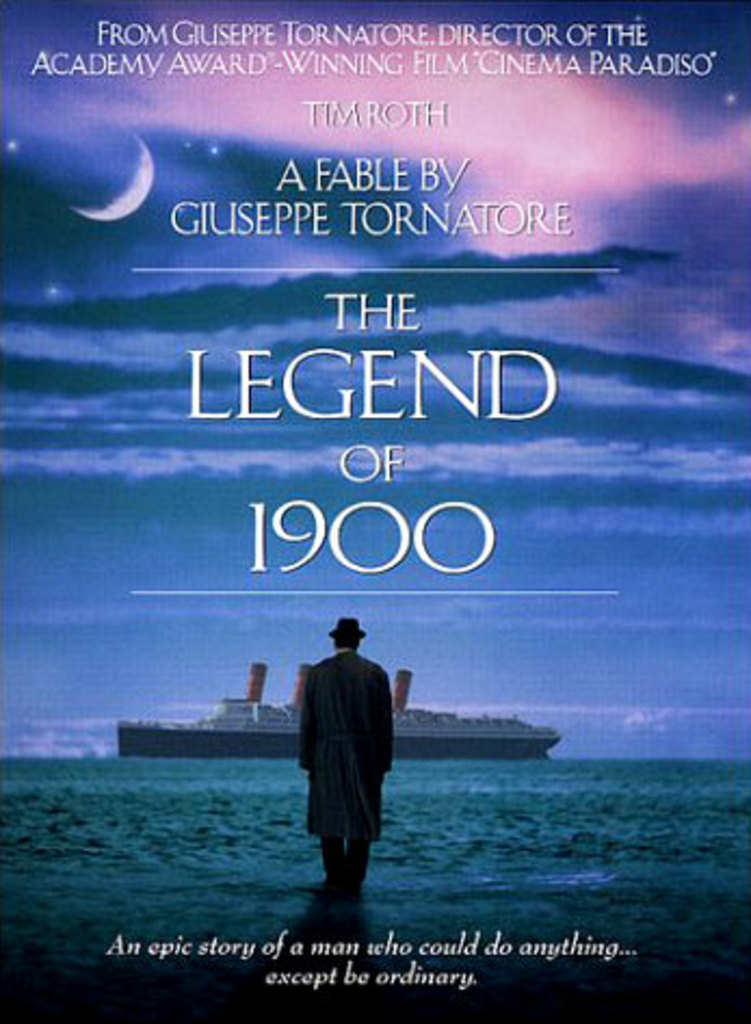What might the symbolism of the ocean and moon suggest in this context? The ocean often symbolizes a vast, uncharted expanse, suggesting adventure and the unknown, which is a direct reflection of the protagonist's life journey on a cruise ship. The moon lighting the ocean can signify guidance, mystery, and the influence of unseen forces in our lives, aligning with the film's theme of a man led by extraordinary talents and experiences. 